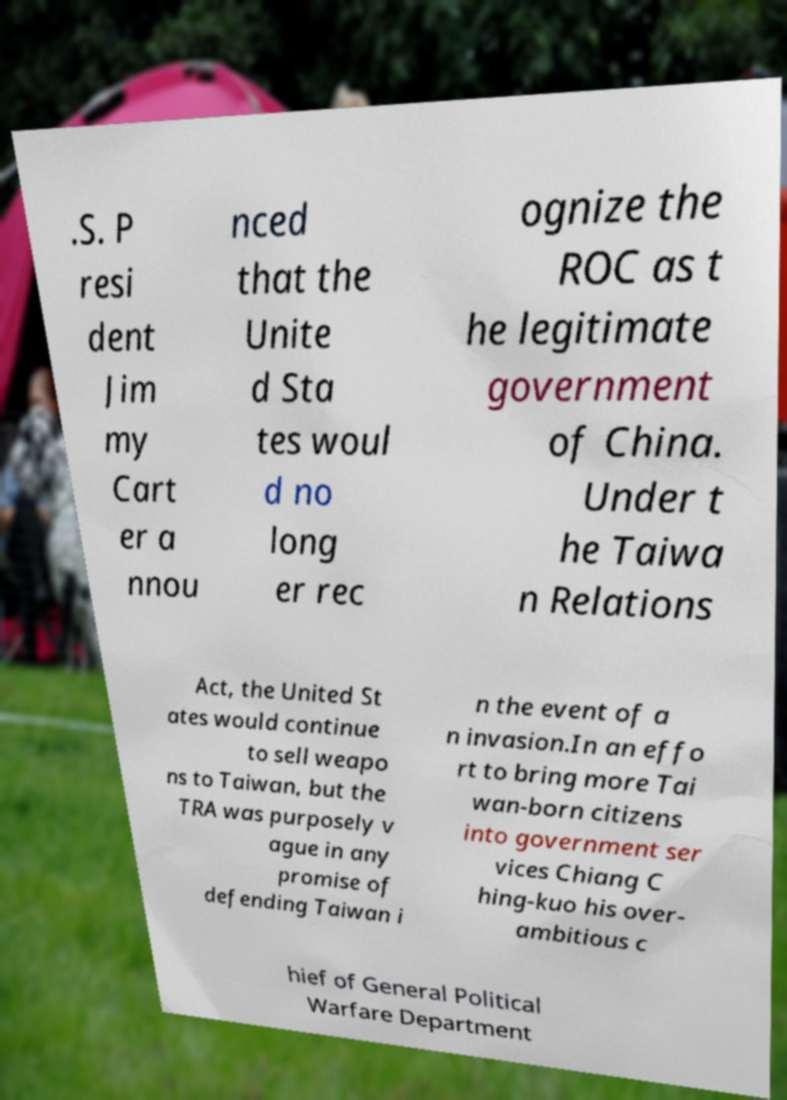There's text embedded in this image that I need extracted. Can you transcribe it verbatim? .S. P resi dent Jim my Cart er a nnou nced that the Unite d Sta tes woul d no long er rec ognize the ROC as t he legitimate government of China. Under t he Taiwa n Relations Act, the United St ates would continue to sell weapo ns to Taiwan, but the TRA was purposely v ague in any promise of defending Taiwan i n the event of a n invasion.In an effo rt to bring more Tai wan-born citizens into government ser vices Chiang C hing-kuo his over- ambitious c hief of General Political Warfare Department 